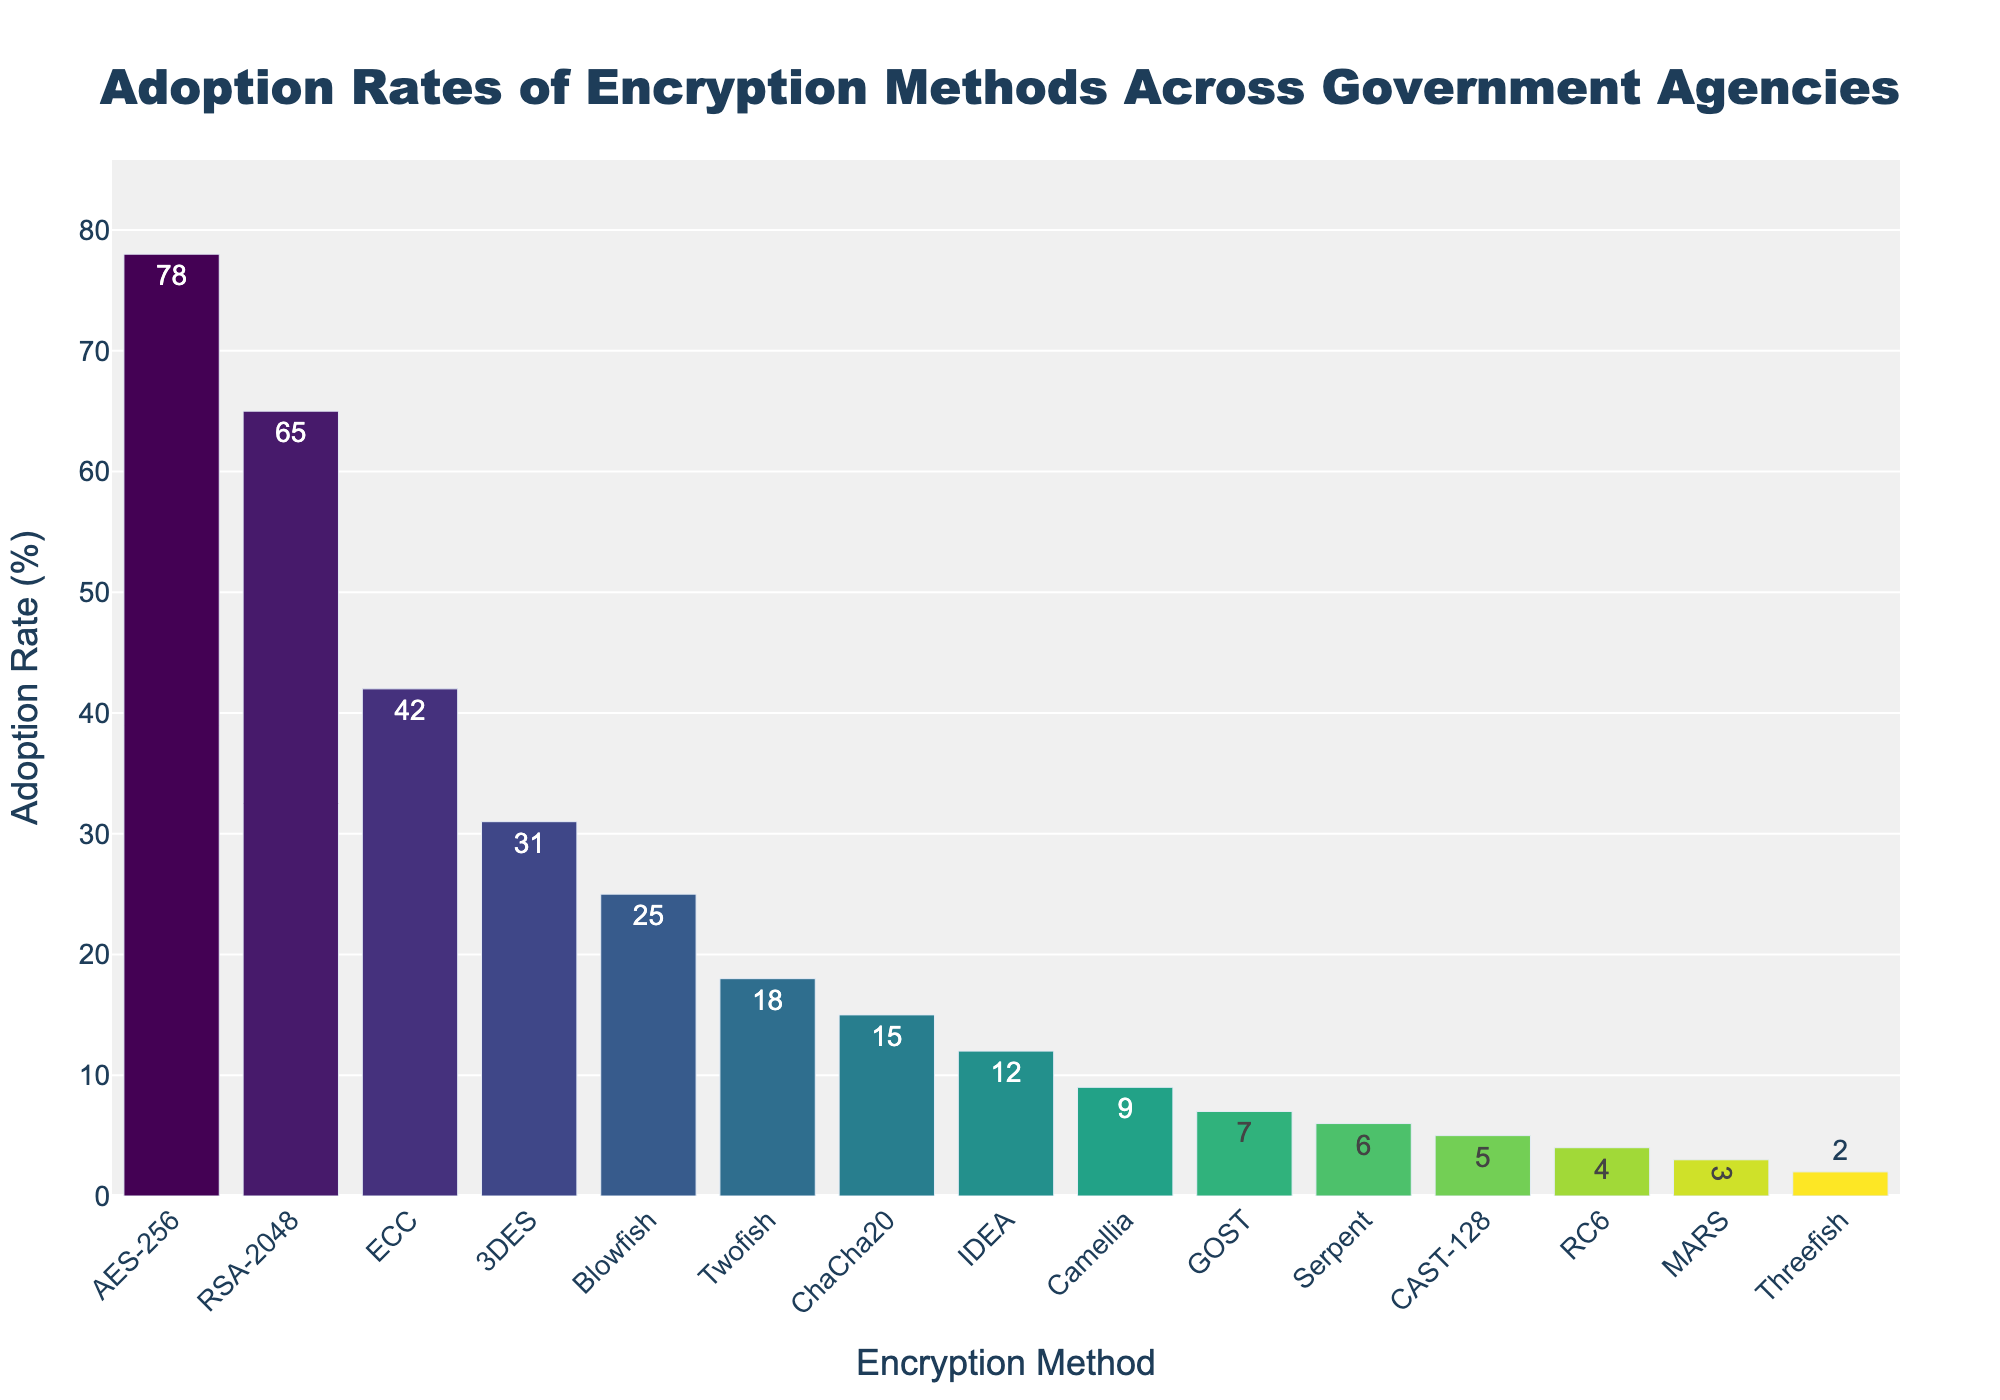Which encryption method has the highest adoption rate? The bar representing AES-256 is the tallest, indicating it has the highest adoption rate.
Answer: AES-256 What is the difference in adoption rates between AES-256 and RSA-2048? The adoption rate of AES-256 is 78%, while RSA-2048 has 65%. The difference is 78 - 65.
Answer: 13% How many encryption methods have an adoption rate of below 10%? Counting the bars with adoption rates marked as below 10%: Camellia, GOST, Serpent, CAST-128, RC6, MARS, and Threefish. There are 7 in total.
Answer: 7 What is the average adoption rate of the top three encryption methods? The adoption rates of the top three methods (AES-256, RSA-2048, ECC) are 78, 65, and 42. Adding these gives 185, and dividing by 3 gives the average.
Answer: 61.67% Which encryption methods have an adoption rate higher than 30%? The encryption methods with adoption rates shown above 30% are: AES-256, RSA-2048, and ECC.
Answer: AES-256, RSA-2048, ECC What is the total adoption rate for encryption methods Blowfish, Twofish, and ChaCha20 combined? The adoption rates for Blowfish, Twofish, and ChaCha20 are 25%, 18%, and 15% respectively. Summing these gives 25 + 18 + 15.
Answer: 58% Which encryption method shows the closest adoption rate to the average adoption rate of all methods? Calculating the average adoption rate of all listed methods: (78 + 65 + 42 + 31 + 25 + 18 + 15 + 12 + 9 + 7 + 6 + 5 + 4 + 3 + 2) / 15 = 22. The method closest to this average is Twofish with 18%.
Answer: Twofish Is the adoption rate of ECC higher than that of 3DES and Blowfish combined? The adoption rate of ECC is 42%. The combined adoption rate of 3DES (31%) and Blowfish (25%) is 31 + 25 = 56%. 42% is less than 56%.
Answer: No What is the median adoption rate among listed encryption methods? Sorting the adoption rates: 2, 3, 4, 5, 6, 7, 9, 12, 15, 18, 25, 31, 42, 65, 78. The middle value in the sorted list of 15 elements is 12.
Answer: 12% Which encryption method has an adoption rate exactly equal to the median value? From the previous calculation, the median adoption rate is 12%. The method with exactly this rate is IDEA.
Answer: IDEA 